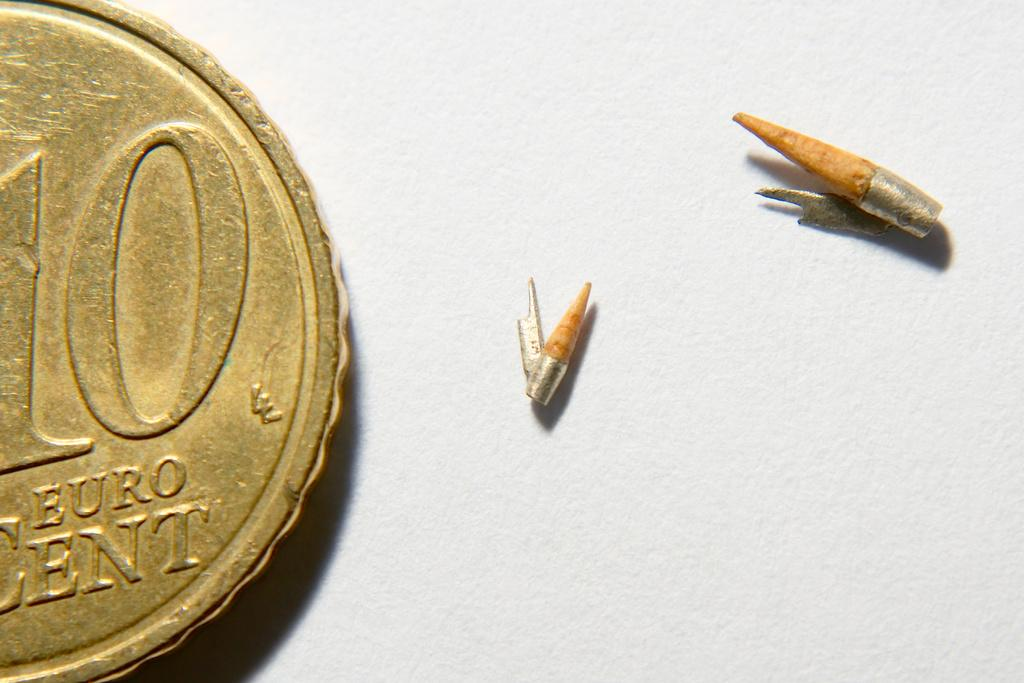<image>
Describe the image concisely. A gold coin with a large 10 and Euro Cent at the bottom. 